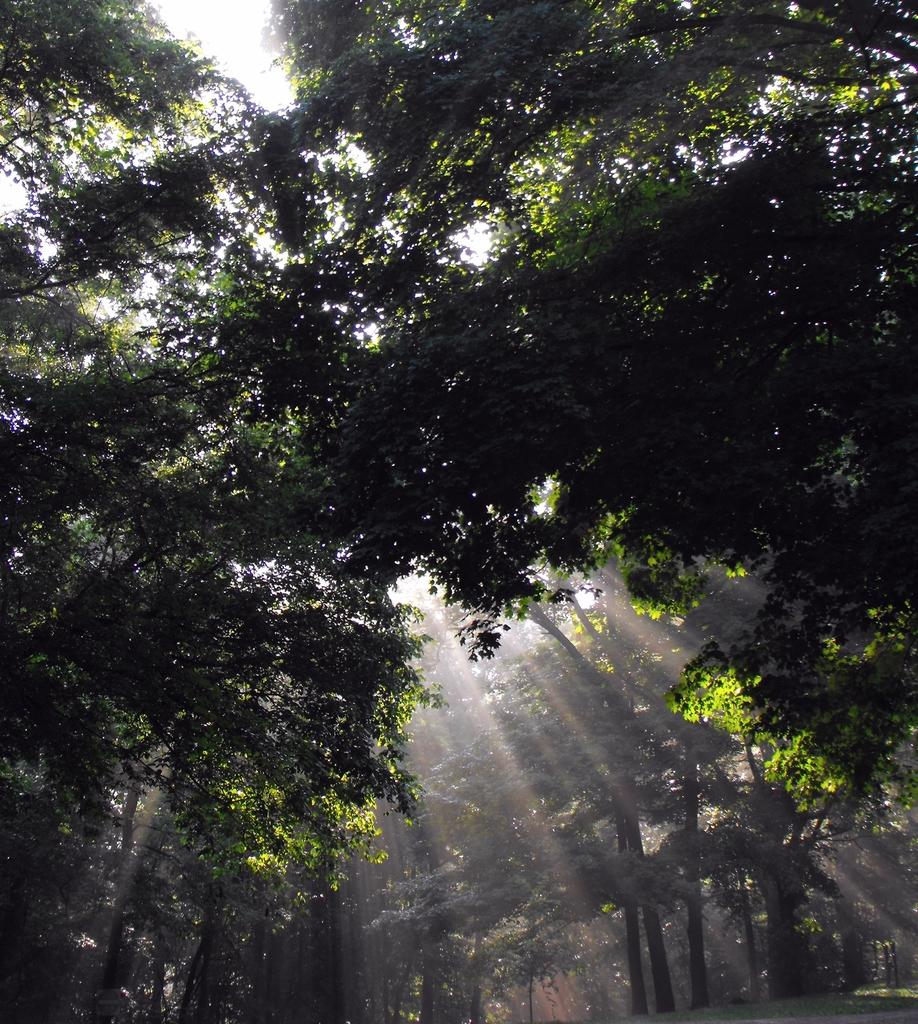What type of vegetation can be seen in the image? There are trees in the image. What else can be seen on the ground in the image? There is grass in the image. What is visible in the background of the image? The sky is visible in the image. Can you see a boat on fire in the image? No, there is no boat or fire present in the image. How many dimes are scattered on the grass in the image? There are no dimes visible in the image; it only features trees, grass, and the sky. 